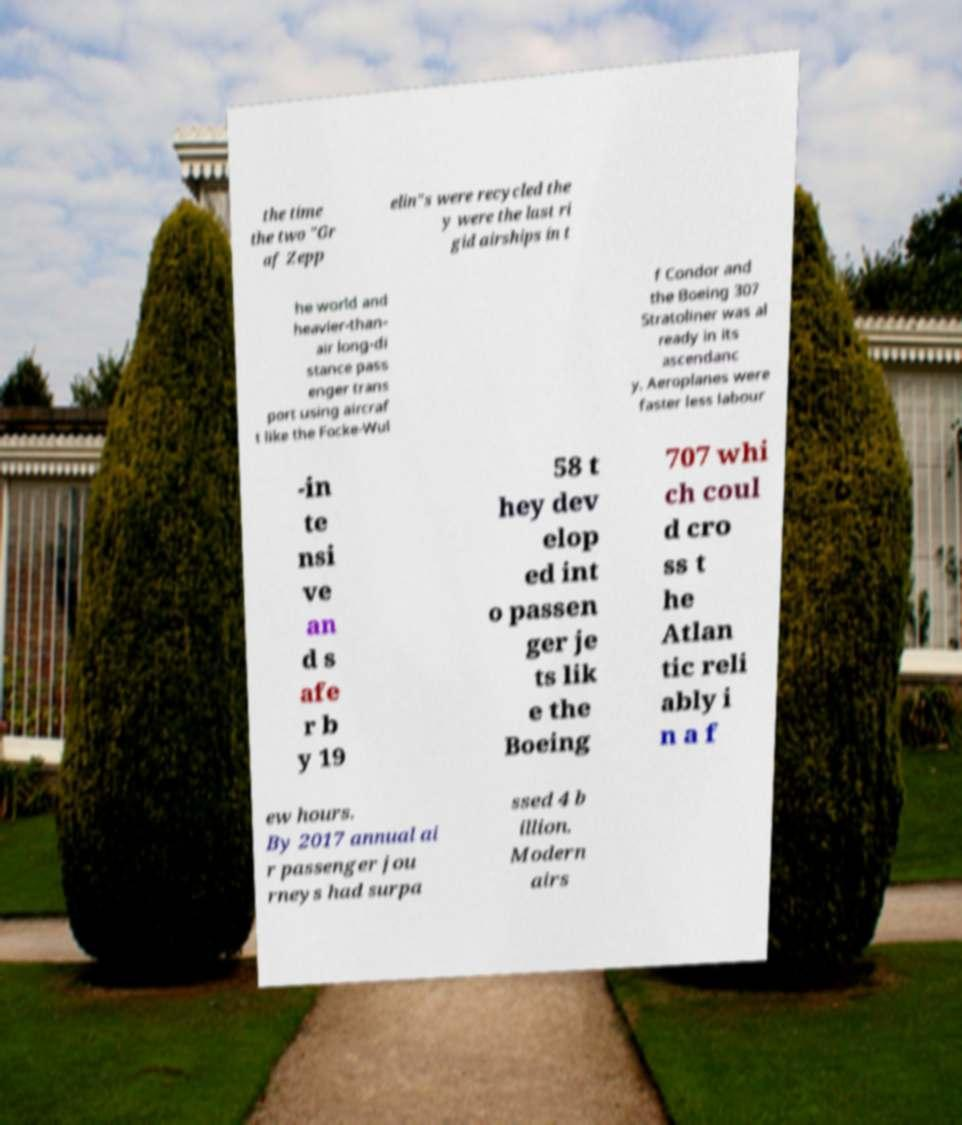Please identify and transcribe the text found in this image. the time the two "Gr af Zepp elin"s were recycled the y were the last ri gid airships in t he world and heavier-than- air long-di stance pass enger trans port using aircraf t like the Focke-Wul f Condor and the Boeing 307 Stratoliner was al ready in its ascendanc y. Aeroplanes were faster less labour -in te nsi ve an d s afe r b y 19 58 t hey dev elop ed int o passen ger je ts lik e the Boeing 707 whi ch coul d cro ss t he Atlan tic reli ably i n a f ew hours. By 2017 annual ai r passenger jou rneys had surpa ssed 4 b illion. Modern airs 